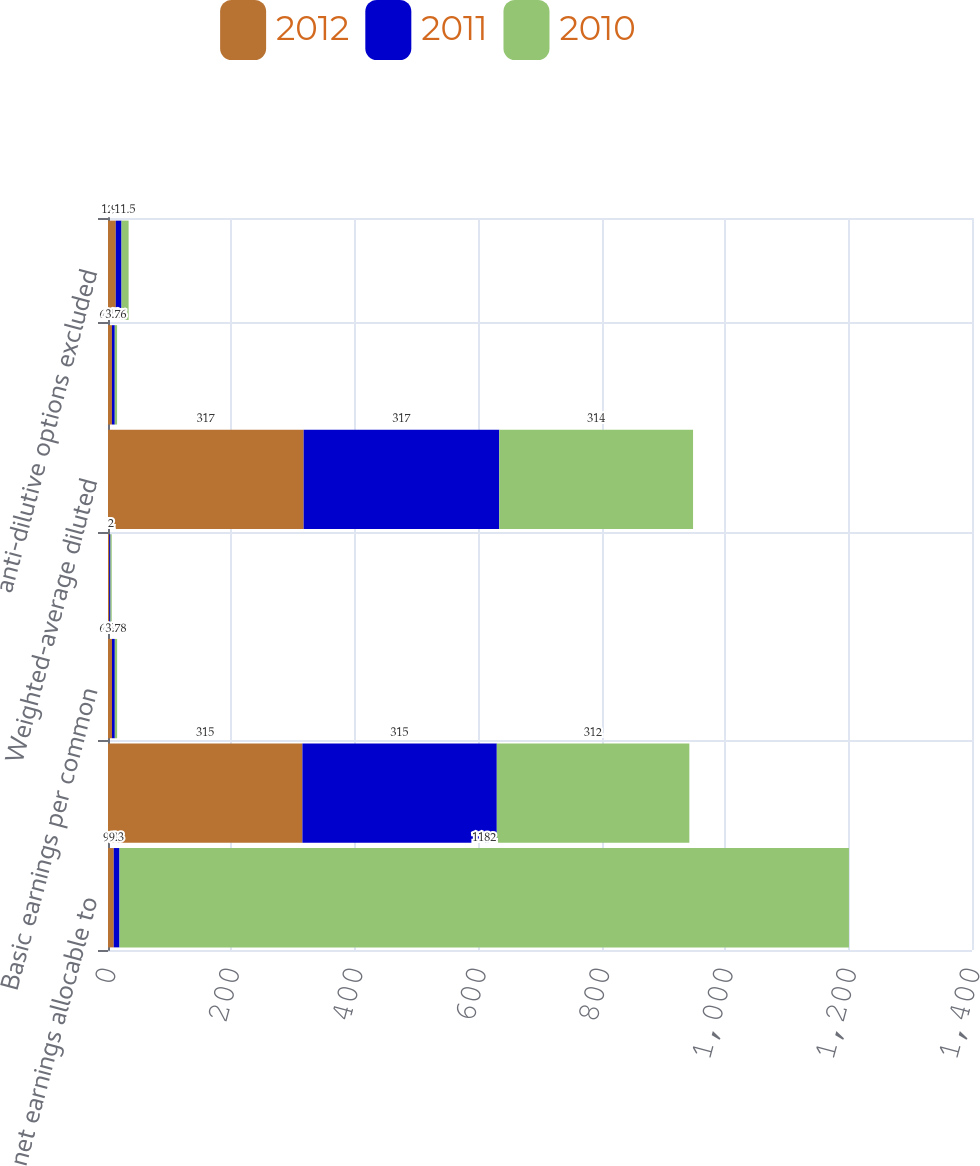<chart> <loc_0><loc_0><loc_500><loc_500><stacked_bar_chart><ecel><fcel>net earnings allocable to<fcel>Weighted-average common shares<fcel>Basic earnings per common<fcel>dilutive effect of share-based<fcel>Weighted-average diluted<fcel>Diluted earnings per common<fcel>anti-dilutive options excluded<nl><fcel>2012<fcel>9.3<fcel>315<fcel>6.44<fcel>2<fcel>317<fcel>6.41<fcel>12.6<nl><fcel>2011<fcel>9.3<fcel>315<fcel>4.61<fcel>2<fcel>317<fcel>4.57<fcel>9.3<nl><fcel>2010<fcel>1182<fcel>312<fcel>3.78<fcel>2<fcel>314<fcel>3.76<fcel>11.5<nl></chart> 